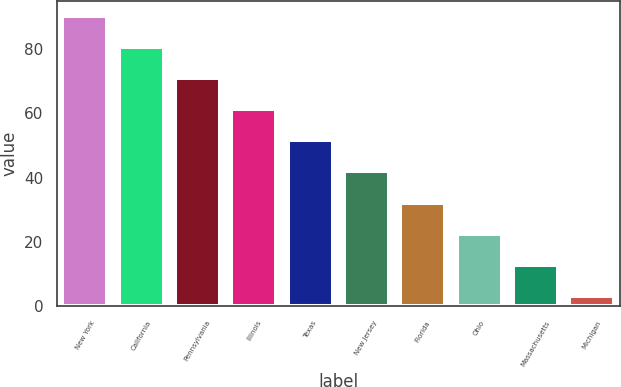Convert chart to OTSL. <chart><loc_0><loc_0><loc_500><loc_500><bar_chart><fcel>New York<fcel>California<fcel>Pennsylvania<fcel>Illinois<fcel>Texas<fcel>New Jersey<fcel>Florida<fcel>Ohio<fcel>Massachusetts<fcel>Michigan<nl><fcel>90.32<fcel>80.64<fcel>70.96<fcel>61.28<fcel>51.6<fcel>41.92<fcel>32.24<fcel>22.56<fcel>12.88<fcel>3.2<nl></chart> 